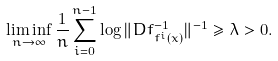<formula> <loc_0><loc_0><loc_500><loc_500>\liminf _ { n \to \infty } \frac { 1 } { n } \sum _ { i = 0 } ^ { n - 1 } \log \| D f _ { f ^ { i } ( x ) } ^ { - 1 } \| ^ { - 1 } \geq \lambda > 0 .</formula> 